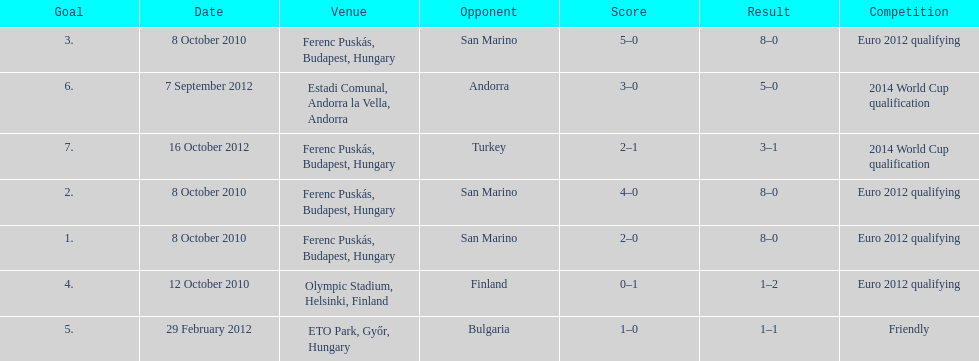How many consecutive games were goals were against san marino? 3. 